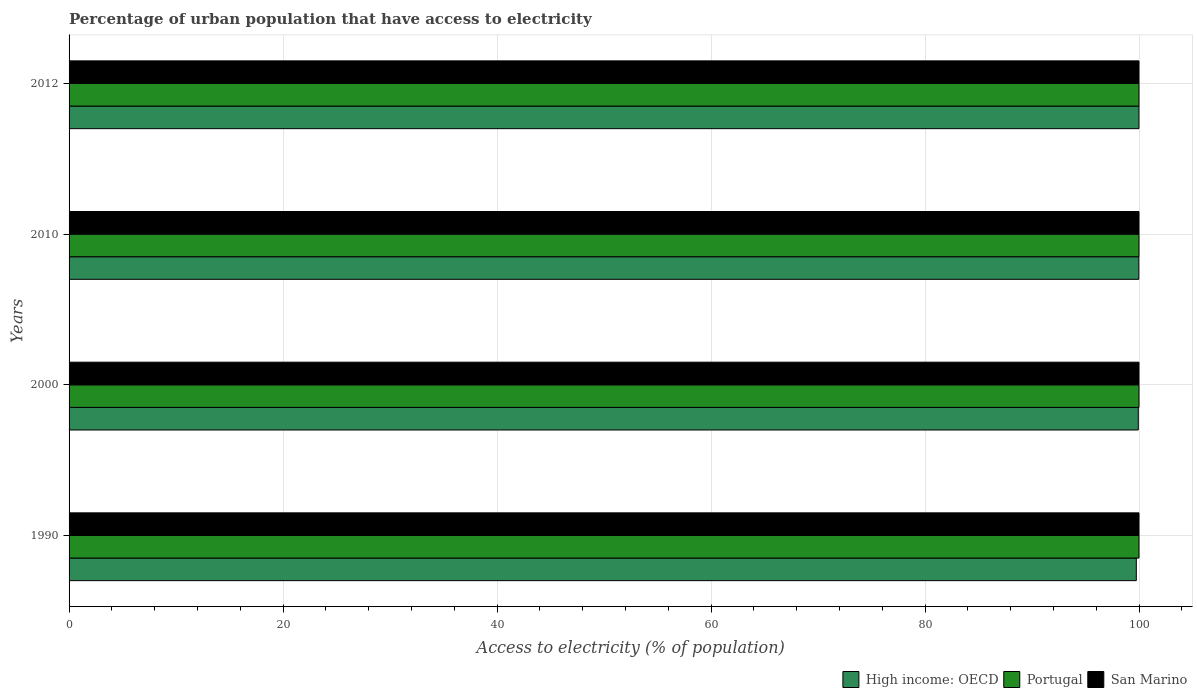How many different coloured bars are there?
Ensure brevity in your answer.  3. How many bars are there on the 2nd tick from the top?
Your answer should be compact. 3. What is the label of the 4th group of bars from the top?
Provide a short and direct response. 1990. In how many cases, is the number of bars for a given year not equal to the number of legend labels?
Your answer should be very brief. 0. What is the percentage of urban population that have access to electricity in Portugal in 1990?
Give a very brief answer. 100. Across all years, what is the maximum percentage of urban population that have access to electricity in High income: OECD?
Your answer should be compact. 100. Across all years, what is the minimum percentage of urban population that have access to electricity in Portugal?
Keep it short and to the point. 100. In which year was the percentage of urban population that have access to electricity in San Marino maximum?
Your answer should be compact. 1990. What is the total percentage of urban population that have access to electricity in High income: OECD in the graph?
Offer a very short reply. 399.67. What is the difference between the percentage of urban population that have access to electricity in High income: OECD in 1990 and that in 2010?
Keep it short and to the point. -0.24. What is the difference between the percentage of urban population that have access to electricity in Portugal in 1990 and the percentage of urban population that have access to electricity in High income: OECD in 2012?
Provide a succinct answer. 0. What is the average percentage of urban population that have access to electricity in San Marino per year?
Your answer should be compact. 100. In the year 1990, what is the difference between the percentage of urban population that have access to electricity in Portugal and percentage of urban population that have access to electricity in San Marino?
Give a very brief answer. 0. What is the ratio of the percentage of urban population that have access to electricity in High income: OECD in 1990 to that in 2010?
Make the answer very short. 1. What is the difference between the highest and the second highest percentage of urban population that have access to electricity in San Marino?
Your answer should be very brief. 0. What does the 2nd bar from the top in 1990 represents?
Make the answer very short. Portugal. What does the 1st bar from the bottom in 1990 represents?
Your answer should be compact. High income: OECD. How many bars are there?
Provide a succinct answer. 12. Are all the bars in the graph horizontal?
Provide a short and direct response. Yes. Does the graph contain any zero values?
Your answer should be compact. No. How many legend labels are there?
Give a very brief answer. 3. How are the legend labels stacked?
Provide a succinct answer. Horizontal. What is the title of the graph?
Provide a succinct answer. Percentage of urban population that have access to electricity. Does "Caribbean small states" appear as one of the legend labels in the graph?
Keep it short and to the point. No. What is the label or title of the X-axis?
Your answer should be very brief. Access to electricity (% of population). What is the Access to electricity (% of population) of High income: OECD in 1990?
Give a very brief answer. 99.75. What is the Access to electricity (% of population) in Portugal in 1990?
Keep it short and to the point. 100. What is the Access to electricity (% of population) of High income: OECD in 2000?
Make the answer very short. 99.94. What is the Access to electricity (% of population) in Portugal in 2000?
Ensure brevity in your answer.  100. What is the Access to electricity (% of population) in San Marino in 2000?
Provide a short and direct response. 100. What is the Access to electricity (% of population) of High income: OECD in 2010?
Offer a terse response. 99.98. What is the Access to electricity (% of population) in San Marino in 2010?
Make the answer very short. 100. What is the Access to electricity (% of population) in High income: OECD in 2012?
Make the answer very short. 100. What is the Access to electricity (% of population) of Portugal in 2012?
Your answer should be compact. 100. Across all years, what is the maximum Access to electricity (% of population) of High income: OECD?
Provide a succinct answer. 100. Across all years, what is the maximum Access to electricity (% of population) of Portugal?
Keep it short and to the point. 100. Across all years, what is the minimum Access to electricity (% of population) of High income: OECD?
Offer a terse response. 99.75. What is the total Access to electricity (% of population) in High income: OECD in the graph?
Make the answer very short. 399.67. What is the difference between the Access to electricity (% of population) in High income: OECD in 1990 and that in 2000?
Your answer should be very brief. -0.19. What is the difference between the Access to electricity (% of population) in High income: OECD in 1990 and that in 2010?
Offer a very short reply. -0.24. What is the difference between the Access to electricity (% of population) of Portugal in 1990 and that in 2010?
Ensure brevity in your answer.  0. What is the difference between the Access to electricity (% of population) in San Marino in 1990 and that in 2010?
Your answer should be very brief. 0. What is the difference between the Access to electricity (% of population) of High income: OECD in 1990 and that in 2012?
Keep it short and to the point. -0.25. What is the difference between the Access to electricity (% of population) in Portugal in 1990 and that in 2012?
Provide a short and direct response. 0. What is the difference between the Access to electricity (% of population) of High income: OECD in 2000 and that in 2010?
Provide a succinct answer. -0.05. What is the difference between the Access to electricity (% of population) of High income: OECD in 2000 and that in 2012?
Make the answer very short. -0.06. What is the difference between the Access to electricity (% of population) of Portugal in 2000 and that in 2012?
Offer a very short reply. 0. What is the difference between the Access to electricity (% of population) of High income: OECD in 2010 and that in 2012?
Provide a short and direct response. -0.01. What is the difference between the Access to electricity (% of population) of High income: OECD in 1990 and the Access to electricity (% of population) of Portugal in 2000?
Keep it short and to the point. -0.25. What is the difference between the Access to electricity (% of population) in High income: OECD in 1990 and the Access to electricity (% of population) in San Marino in 2000?
Provide a short and direct response. -0.25. What is the difference between the Access to electricity (% of population) of High income: OECD in 1990 and the Access to electricity (% of population) of Portugal in 2010?
Ensure brevity in your answer.  -0.25. What is the difference between the Access to electricity (% of population) in High income: OECD in 1990 and the Access to electricity (% of population) in San Marino in 2010?
Ensure brevity in your answer.  -0.25. What is the difference between the Access to electricity (% of population) in Portugal in 1990 and the Access to electricity (% of population) in San Marino in 2010?
Your response must be concise. 0. What is the difference between the Access to electricity (% of population) in High income: OECD in 1990 and the Access to electricity (% of population) in Portugal in 2012?
Ensure brevity in your answer.  -0.25. What is the difference between the Access to electricity (% of population) in High income: OECD in 1990 and the Access to electricity (% of population) in San Marino in 2012?
Provide a succinct answer. -0.25. What is the difference between the Access to electricity (% of population) of Portugal in 1990 and the Access to electricity (% of population) of San Marino in 2012?
Make the answer very short. 0. What is the difference between the Access to electricity (% of population) of High income: OECD in 2000 and the Access to electricity (% of population) of Portugal in 2010?
Your answer should be very brief. -0.06. What is the difference between the Access to electricity (% of population) in High income: OECD in 2000 and the Access to electricity (% of population) in San Marino in 2010?
Your answer should be very brief. -0.06. What is the difference between the Access to electricity (% of population) in High income: OECD in 2000 and the Access to electricity (% of population) in Portugal in 2012?
Offer a very short reply. -0.06. What is the difference between the Access to electricity (% of population) in High income: OECD in 2000 and the Access to electricity (% of population) in San Marino in 2012?
Ensure brevity in your answer.  -0.06. What is the difference between the Access to electricity (% of population) in High income: OECD in 2010 and the Access to electricity (% of population) in Portugal in 2012?
Your answer should be compact. -0.02. What is the difference between the Access to electricity (% of population) of High income: OECD in 2010 and the Access to electricity (% of population) of San Marino in 2012?
Your answer should be compact. -0.02. What is the difference between the Access to electricity (% of population) of Portugal in 2010 and the Access to electricity (% of population) of San Marino in 2012?
Give a very brief answer. 0. What is the average Access to electricity (% of population) in High income: OECD per year?
Give a very brief answer. 99.92. What is the average Access to electricity (% of population) of Portugal per year?
Ensure brevity in your answer.  100. What is the average Access to electricity (% of population) in San Marino per year?
Your answer should be very brief. 100. In the year 1990, what is the difference between the Access to electricity (% of population) of High income: OECD and Access to electricity (% of population) of Portugal?
Make the answer very short. -0.25. In the year 1990, what is the difference between the Access to electricity (% of population) in High income: OECD and Access to electricity (% of population) in San Marino?
Provide a short and direct response. -0.25. In the year 1990, what is the difference between the Access to electricity (% of population) of Portugal and Access to electricity (% of population) of San Marino?
Provide a succinct answer. 0. In the year 2000, what is the difference between the Access to electricity (% of population) in High income: OECD and Access to electricity (% of population) in Portugal?
Give a very brief answer. -0.06. In the year 2000, what is the difference between the Access to electricity (% of population) in High income: OECD and Access to electricity (% of population) in San Marino?
Your answer should be compact. -0.06. In the year 2000, what is the difference between the Access to electricity (% of population) in Portugal and Access to electricity (% of population) in San Marino?
Keep it short and to the point. 0. In the year 2010, what is the difference between the Access to electricity (% of population) in High income: OECD and Access to electricity (% of population) in Portugal?
Provide a short and direct response. -0.02. In the year 2010, what is the difference between the Access to electricity (% of population) in High income: OECD and Access to electricity (% of population) in San Marino?
Offer a very short reply. -0.02. In the year 2012, what is the difference between the Access to electricity (% of population) in High income: OECD and Access to electricity (% of population) in Portugal?
Give a very brief answer. -0. In the year 2012, what is the difference between the Access to electricity (% of population) in High income: OECD and Access to electricity (% of population) in San Marino?
Provide a short and direct response. -0. In the year 2012, what is the difference between the Access to electricity (% of population) in Portugal and Access to electricity (% of population) in San Marino?
Ensure brevity in your answer.  0. What is the ratio of the Access to electricity (% of population) of Portugal in 1990 to that in 2000?
Keep it short and to the point. 1. What is the ratio of the Access to electricity (% of population) in Portugal in 1990 to that in 2010?
Provide a short and direct response. 1. What is the ratio of the Access to electricity (% of population) of High income: OECD in 2000 to that in 2010?
Your answer should be very brief. 1. What is the ratio of the Access to electricity (% of population) in Portugal in 2000 to that in 2012?
Give a very brief answer. 1. What is the ratio of the Access to electricity (% of population) in San Marino in 2010 to that in 2012?
Your response must be concise. 1. What is the difference between the highest and the second highest Access to electricity (% of population) of High income: OECD?
Your response must be concise. 0.01. What is the difference between the highest and the lowest Access to electricity (% of population) in High income: OECD?
Your answer should be very brief. 0.25. 